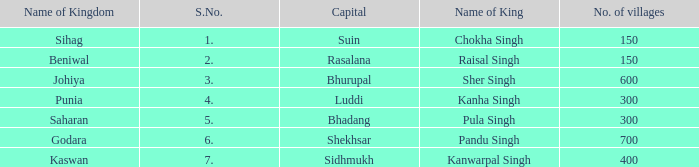Which kingdom has Suin as its capital? Sihag. Could you parse the entire table? {'header': ['Name of Kingdom', 'S.No.', 'Capital', 'Name of King', 'No. of villages'], 'rows': [['Sihag', '1.', 'Suin', 'Chokha Singh', '150'], ['Beniwal', '2.', 'Rasalana', 'Raisal Singh', '150'], ['Johiya', '3.', 'Bhurupal', 'Sher Singh', '600'], ['Punia', '4.', 'Luddi', 'Kanha Singh', '300'], ['Saharan', '5.', 'Bhadang', 'Pula Singh', '300'], ['Godara', '6.', 'Shekhsar', 'Pandu Singh', '700'], ['Kaswan', '7.', 'Sidhmukh', 'Kanwarpal Singh', '400']]} 